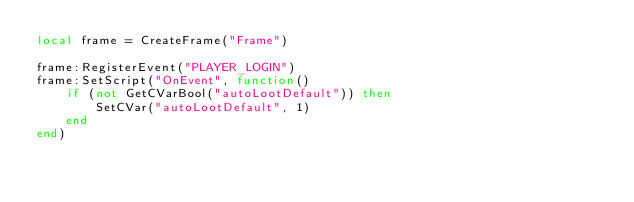<code> <loc_0><loc_0><loc_500><loc_500><_Lua_>local frame = CreateFrame("Frame")

frame:RegisterEvent("PLAYER_LOGIN")
frame:SetScript("OnEvent", function()
	if (not GetCVarBool("autoLootDefault")) then
		SetCVar("autoLootDefault", 1)
	end
end)</code> 